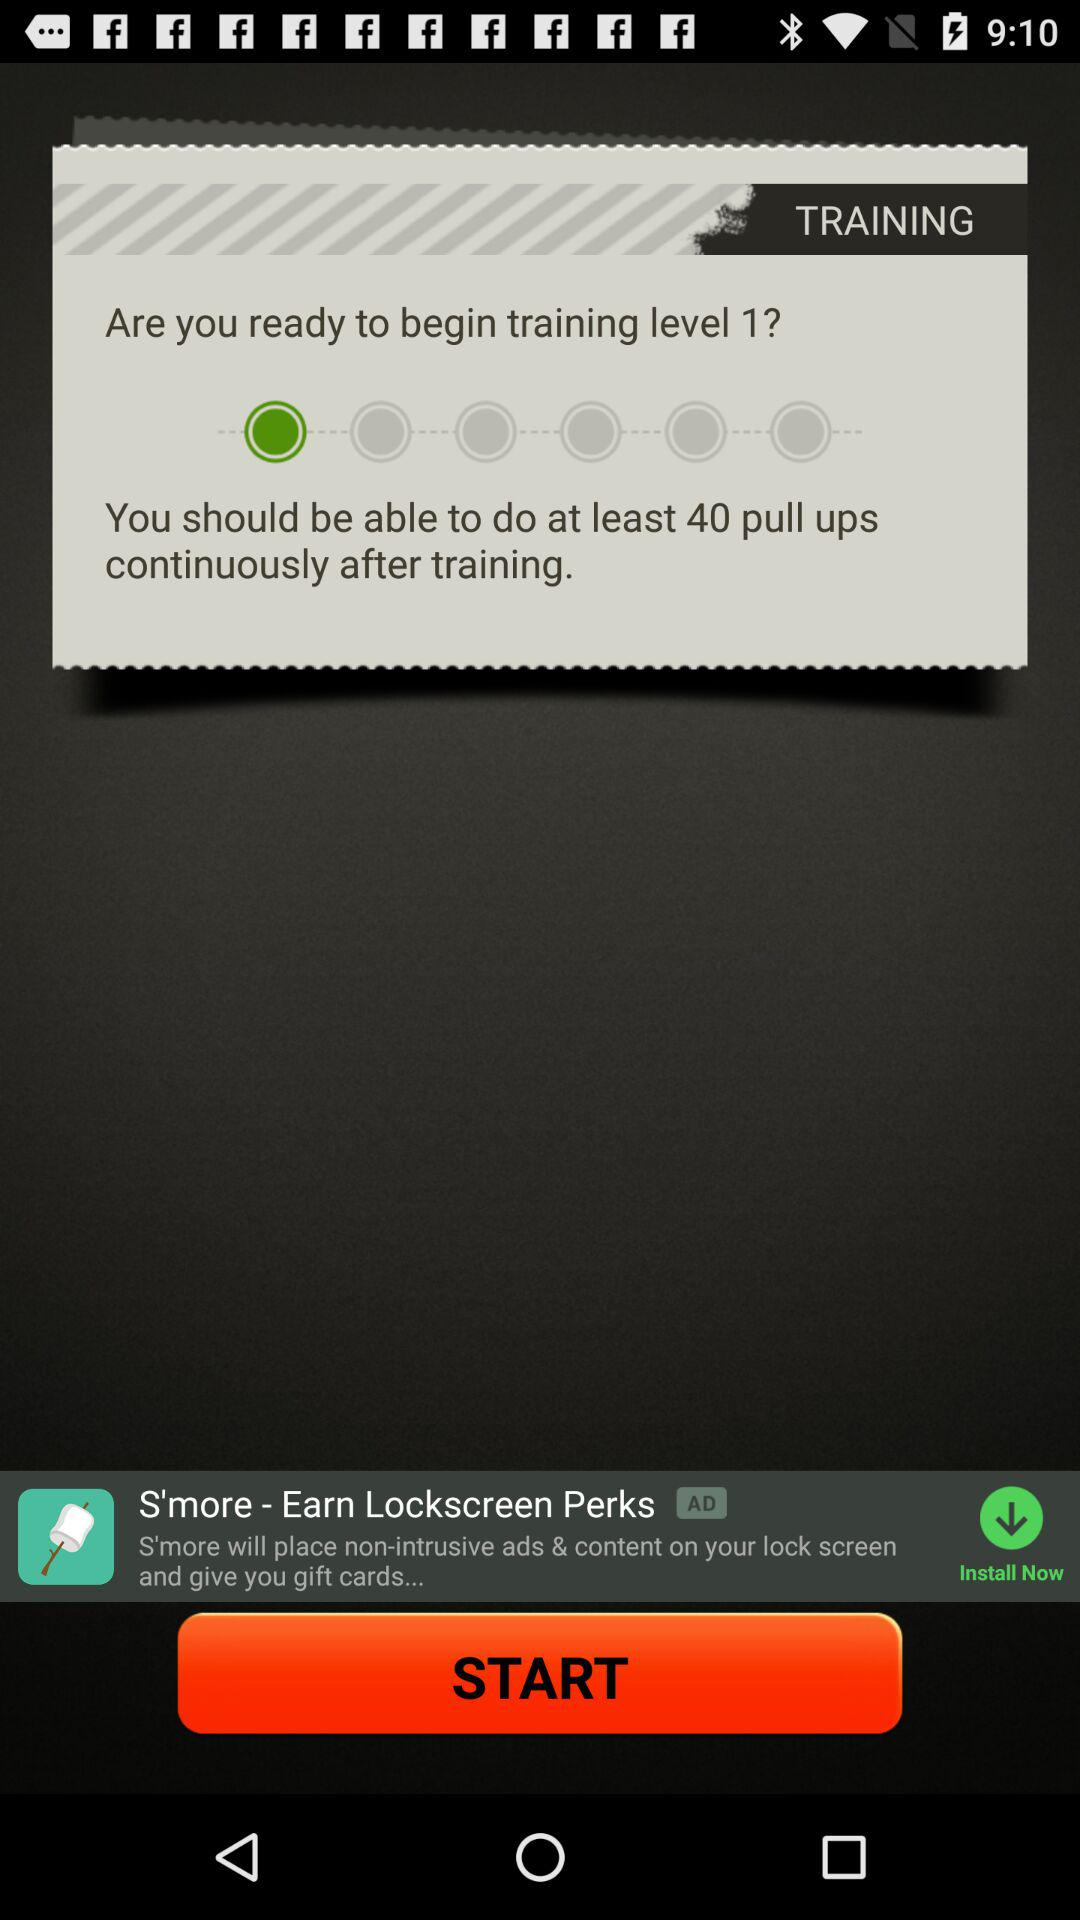How many pull ups we should do after training level 1? You should do at least 40 pull ups after training level 1. 